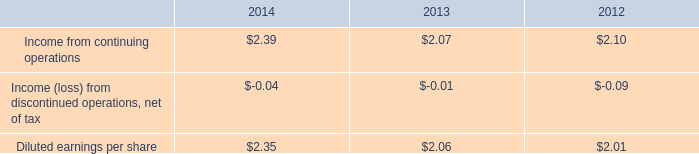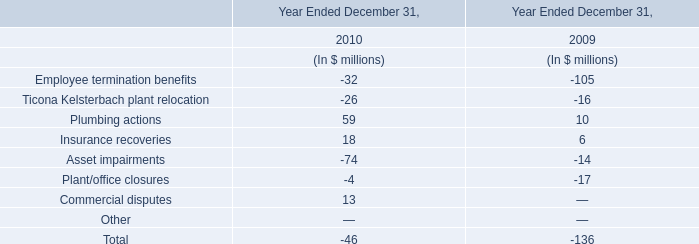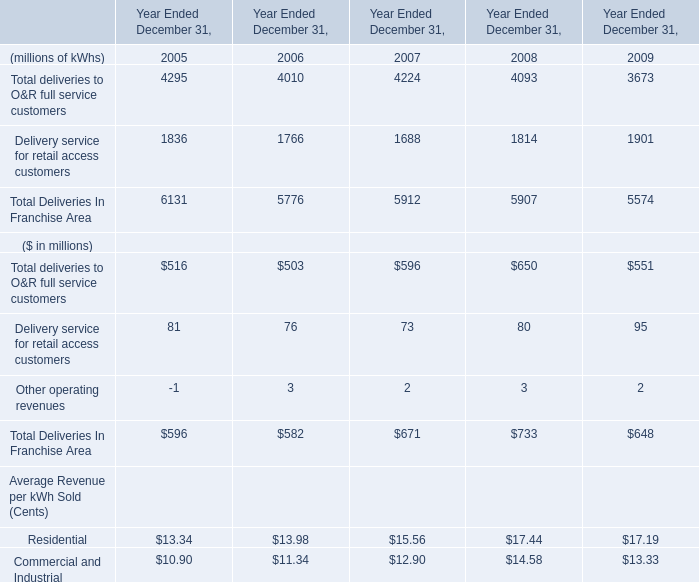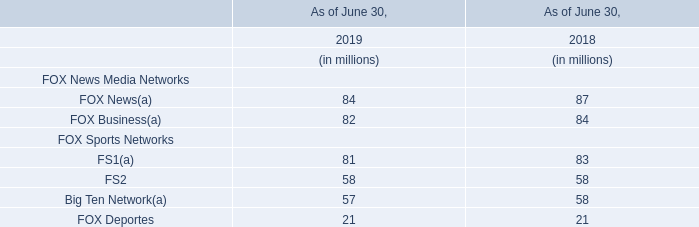What is the ratio of Delivery service for retail access customers to the total in 2005? 
Computations: (1836 / 6131)
Answer: 0.29946. 